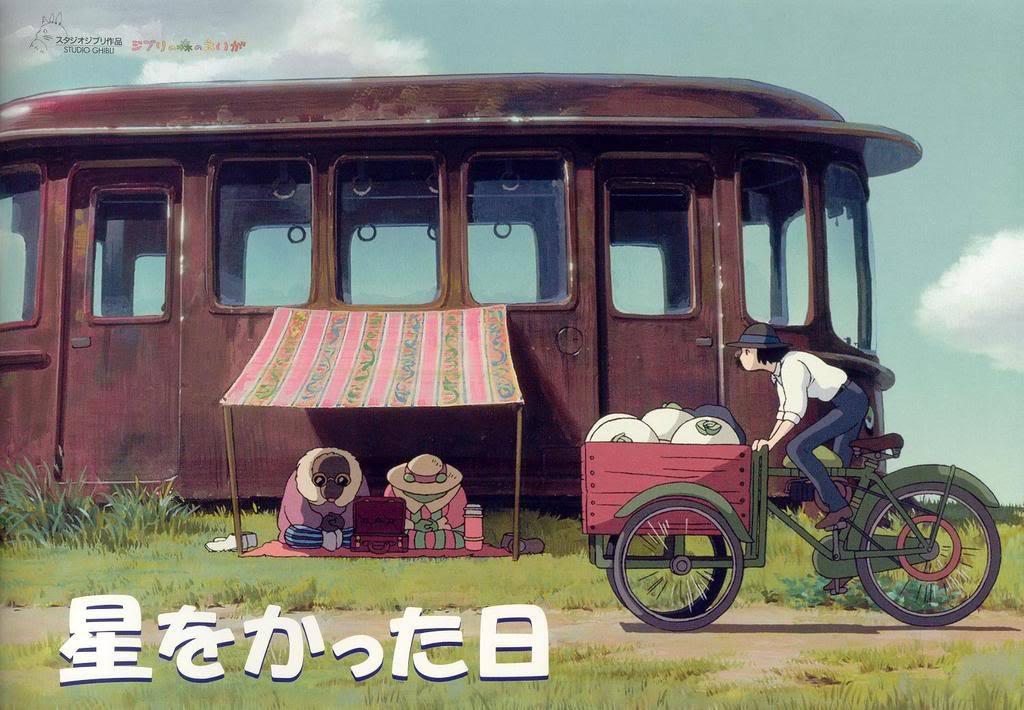What type of landscape is depicted in the image? The image contains a grassland. Are there any living beings in the image? Yes, there are people in the image. What else can be seen in the image besides the grassland and people? Vehicles are present in the image. What is visible in the background of the image? The sky is visible in the image. What type of spark can be seen coming from the people in the image? There is no spark present in the image; it features people in a grassland setting. How many girls are visible in the image? The provided facts do not specify the gender of the people in the image, so it cannot be determined how many girls are visible. 